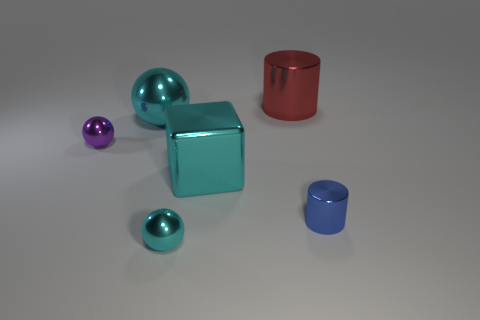What size is the cylinder that is right of the large red shiny cylinder?
Offer a terse response. Small. Are there any other things that are the same size as the block?
Your response must be concise. Yes. There is a shiny thing that is both to the left of the cyan cube and behind the tiny purple metallic thing; what is its color?
Keep it short and to the point. Cyan. Does the tiny sphere that is on the right side of the purple shiny ball have the same material as the large sphere?
Keep it short and to the point. Yes. There is a big shiny block; is it the same color as the small metallic sphere that is on the right side of the large cyan ball?
Ensure brevity in your answer.  Yes. There is a small metallic cylinder; are there any tiny things on the right side of it?
Give a very brief answer. No. There is a sphere that is in front of the tiny blue metal cylinder; is its size the same as the shiny cylinder that is to the left of the blue shiny cylinder?
Provide a succinct answer. No. Is there a blue shiny cylinder that has the same size as the purple sphere?
Your response must be concise. Yes. There is a small metal object in front of the tiny metallic cylinder; is its shape the same as the tiny purple shiny thing?
Your response must be concise. Yes. There is a sphere that is in front of the purple metallic sphere; what is its material?
Offer a very short reply. Metal. 